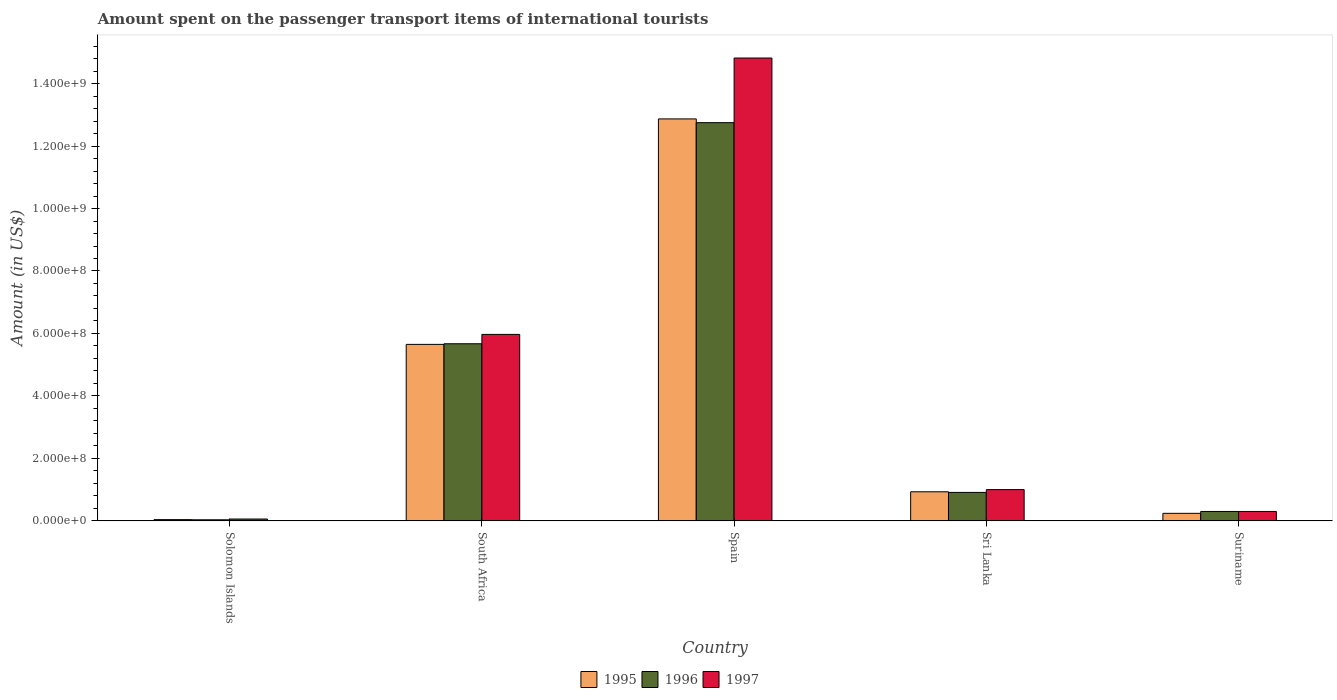How many different coloured bars are there?
Give a very brief answer. 3. How many groups of bars are there?
Provide a short and direct response. 5. Are the number of bars on each tick of the X-axis equal?
Ensure brevity in your answer.  Yes. How many bars are there on the 2nd tick from the left?
Ensure brevity in your answer.  3. How many bars are there on the 4th tick from the right?
Your answer should be very brief. 3. What is the label of the 1st group of bars from the left?
Offer a terse response. Solomon Islands. In how many cases, is the number of bars for a given country not equal to the number of legend labels?
Ensure brevity in your answer.  0. What is the amount spent on the passenger transport items of international tourists in 1997 in Solomon Islands?
Give a very brief answer. 5.80e+06. Across all countries, what is the maximum amount spent on the passenger transport items of international tourists in 1997?
Keep it short and to the point. 1.48e+09. Across all countries, what is the minimum amount spent on the passenger transport items of international tourists in 1995?
Provide a short and direct response. 3.90e+06. In which country was the amount spent on the passenger transport items of international tourists in 1996 minimum?
Ensure brevity in your answer.  Solomon Islands. What is the total amount spent on the passenger transport items of international tourists in 1996 in the graph?
Provide a short and direct response. 1.97e+09. What is the difference between the amount spent on the passenger transport items of international tourists in 1996 in Spain and that in Sri Lanka?
Keep it short and to the point. 1.18e+09. What is the difference between the amount spent on the passenger transport items of international tourists in 1995 in South Africa and the amount spent on the passenger transport items of international tourists in 1996 in Spain?
Make the answer very short. -7.10e+08. What is the average amount spent on the passenger transport items of international tourists in 1995 per country?
Ensure brevity in your answer.  3.95e+08. In how many countries, is the amount spent on the passenger transport items of international tourists in 1995 greater than 1400000000 US$?
Your answer should be very brief. 0. What is the ratio of the amount spent on the passenger transport items of international tourists in 1996 in Spain to that in Sri Lanka?
Give a very brief answer. 14.01. Is the amount spent on the passenger transport items of international tourists in 1996 in Spain less than that in Suriname?
Offer a very short reply. No. What is the difference between the highest and the second highest amount spent on the passenger transport items of international tourists in 1997?
Ensure brevity in your answer.  1.38e+09. What is the difference between the highest and the lowest amount spent on the passenger transport items of international tourists in 1997?
Give a very brief answer. 1.48e+09. What does the 1st bar from the right in Sri Lanka represents?
Your answer should be very brief. 1997. How many countries are there in the graph?
Your response must be concise. 5. What is the difference between two consecutive major ticks on the Y-axis?
Your answer should be compact. 2.00e+08. Are the values on the major ticks of Y-axis written in scientific E-notation?
Your response must be concise. Yes. Does the graph contain grids?
Keep it short and to the point. No. Where does the legend appear in the graph?
Provide a short and direct response. Bottom center. How are the legend labels stacked?
Make the answer very short. Horizontal. What is the title of the graph?
Your answer should be compact. Amount spent on the passenger transport items of international tourists. Does "2004" appear as one of the legend labels in the graph?
Provide a short and direct response. No. What is the label or title of the Y-axis?
Provide a short and direct response. Amount (in US$). What is the Amount (in US$) in 1995 in Solomon Islands?
Offer a terse response. 3.90e+06. What is the Amount (in US$) of 1996 in Solomon Islands?
Offer a very short reply. 3.30e+06. What is the Amount (in US$) of 1997 in Solomon Islands?
Keep it short and to the point. 5.80e+06. What is the Amount (in US$) in 1995 in South Africa?
Provide a short and direct response. 5.65e+08. What is the Amount (in US$) in 1996 in South Africa?
Ensure brevity in your answer.  5.67e+08. What is the Amount (in US$) in 1997 in South Africa?
Your answer should be very brief. 5.97e+08. What is the Amount (in US$) of 1995 in Spain?
Your answer should be very brief. 1.29e+09. What is the Amount (in US$) in 1996 in Spain?
Your answer should be very brief. 1.28e+09. What is the Amount (in US$) of 1997 in Spain?
Offer a very short reply. 1.48e+09. What is the Amount (in US$) of 1995 in Sri Lanka?
Provide a succinct answer. 9.30e+07. What is the Amount (in US$) in 1996 in Sri Lanka?
Give a very brief answer. 9.10e+07. What is the Amount (in US$) of 1995 in Suriname?
Your answer should be compact. 2.40e+07. What is the Amount (in US$) of 1996 in Suriname?
Make the answer very short. 3.00e+07. What is the Amount (in US$) of 1997 in Suriname?
Ensure brevity in your answer.  3.00e+07. Across all countries, what is the maximum Amount (in US$) of 1995?
Your answer should be compact. 1.29e+09. Across all countries, what is the maximum Amount (in US$) in 1996?
Your response must be concise. 1.28e+09. Across all countries, what is the maximum Amount (in US$) in 1997?
Provide a succinct answer. 1.48e+09. Across all countries, what is the minimum Amount (in US$) in 1995?
Your response must be concise. 3.90e+06. Across all countries, what is the minimum Amount (in US$) of 1996?
Provide a short and direct response. 3.30e+06. Across all countries, what is the minimum Amount (in US$) in 1997?
Offer a very short reply. 5.80e+06. What is the total Amount (in US$) of 1995 in the graph?
Give a very brief answer. 1.97e+09. What is the total Amount (in US$) in 1996 in the graph?
Give a very brief answer. 1.97e+09. What is the total Amount (in US$) of 1997 in the graph?
Offer a very short reply. 2.21e+09. What is the difference between the Amount (in US$) in 1995 in Solomon Islands and that in South Africa?
Keep it short and to the point. -5.61e+08. What is the difference between the Amount (in US$) of 1996 in Solomon Islands and that in South Africa?
Offer a terse response. -5.64e+08. What is the difference between the Amount (in US$) in 1997 in Solomon Islands and that in South Africa?
Make the answer very short. -5.91e+08. What is the difference between the Amount (in US$) of 1995 in Solomon Islands and that in Spain?
Keep it short and to the point. -1.28e+09. What is the difference between the Amount (in US$) in 1996 in Solomon Islands and that in Spain?
Give a very brief answer. -1.27e+09. What is the difference between the Amount (in US$) of 1997 in Solomon Islands and that in Spain?
Offer a terse response. -1.48e+09. What is the difference between the Amount (in US$) of 1995 in Solomon Islands and that in Sri Lanka?
Make the answer very short. -8.91e+07. What is the difference between the Amount (in US$) of 1996 in Solomon Islands and that in Sri Lanka?
Your answer should be very brief. -8.77e+07. What is the difference between the Amount (in US$) in 1997 in Solomon Islands and that in Sri Lanka?
Give a very brief answer. -9.42e+07. What is the difference between the Amount (in US$) of 1995 in Solomon Islands and that in Suriname?
Keep it short and to the point. -2.01e+07. What is the difference between the Amount (in US$) in 1996 in Solomon Islands and that in Suriname?
Your answer should be very brief. -2.67e+07. What is the difference between the Amount (in US$) in 1997 in Solomon Islands and that in Suriname?
Keep it short and to the point. -2.42e+07. What is the difference between the Amount (in US$) in 1995 in South Africa and that in Spain?
Ensure brevity in your answer.  -7.22e+08. What is the difference between the Amount (in US$) in 1996 in South Africa and that in Spain?
Your answer should be compact. -7.08e+08. What is the difference between the Amount (in US$) of 1997 in South Africa and that in Spain?
Make the answer very short. -8.85e+08. What is the difference between the Amount (in US$) of 1995 in South Africa and that in Sri Lanka?
Provide a short and direct response. 4.72e+08. What is the difference between the Amount (in US$) of 1996 in South Africa and that in Sri Lanka?
Provide a short and direct response. 4.76e+08. What is the difference between the Amount (in US$) of 1997 in South Africa and that in Sri Lanka?
Ensure brevity in your answer.  4.97e+08. What is the difference between the Amount (in US$) in 1995 in South Africa and that in Suriname?
Give a very brief answer. 5.41e+08. What is the difference between the Amount (in US$) of 1996 in South Africa and that in Suriname?
Offer a very short reply. 5.37e+08. What is the difference between the Amount (in US$) in 1997 in South Africa and that in Suriname?
Provide a succinct answer. 5.67e+08. What is the difference between the Amount (in US$) in 1995 in Spain and that in Sri Lanka?
Give a very brief answer. 1.19e+09. What is the difference between the Amount (in US$) of 1996 in Spain and that in Sri Lanka?
Offer a terse response. 1.18e+09. What is the difference between the Amount (in US$) in 1997 in Spain and that in Sri Lanka?
Your response must be concise. 1.38e+09. What is the difference between the Amount (in US$) in 1995 in Spain and that in Suriname?
Ensure brevity in your answer.  1.26e+09. What is the difference between the Amount (in US$) in 1996 in Spain and that in Suriname?
Offer a terse response. 1.24e+09. What is the difference between the Amount (in US$) in 1997 in Spain and that in Suriname?
Your response must be concise. 1.45e+09. What is the difference between the Amount (in US$) of 1995 in Sri Lanka and that in Suriname?
Make the answer very short. 6.90e+07. What is the difference between the Amount (in US$) in 1996 in Sri Lanka and that in Suriname?
Keep it short and to the point. 6.10e+07. What is the difference between the Amount (in US$) in 1997 in Sri Lanka and that in Suriname?
Ensure brevity in your answer.  7.00e+07. What is the difference between the Amount (in US$) in 1995 in Solomon Islands and the Amount (in US$) in 1996 in South Africa?
Your answer should be very brief. -5.63e+08. What is the difference between the Amount (in US$) of 1995 in Solomon Islands and the Amount (in US$) of 1997 in South Africa?
Provide a succinct answer. -5.93e+08. What is the difference between the Amount (in US$) of 1996 in Solomon Islands and the Amount (in US$) of 1997 in South Africa?
Give a very brief answer. -5.94e+08. What is the difference between the Amount (in US$) of 1995 in Solomon Islands and the Amount (in US$) of 1996 in Spain?
Your response must be concise. -1.27e+09. What is the difference between the Amount (in US$) of 1995 in Solomon Islands and the Amount (in US$) of 1997 in Spain?
Give a very brief answer. -1.48e+09. What is the difference between the Amount (in US$) in 1996 in Solomon Islands and the Amount (in US$) in 1997 in Spain?
Ensure brevity in your answer.  -1.48e+09. What is the difference between the Amount (in US$) of 1995 in Solomon Islands and the Amount (in US$) of 1996 in Sri Lanka?
Your answer should be compact. -8.71e+07. What is the difference between the Amount (in US$) of 1995 in Solomon Islands and the Amount (in US$) of 1997 in Sri Lanka?
Your answer should be very brief. -9.61e+07. What is the difference between the Amount (in US$) in 1996 in Solomon Islands and the Amount (in US$) in 1997 in Sri Lanka?
Offer a terse response. -9.67e+07. What is the difference between the Amount (in US$) in 1995 in Solomon Islands and the Amount (in US$) in 1996 in Suriname?
Ensure brevity in your answer.  -2.61e+07. What is the difference between the Amount (in US$) in 1995 in Solomon Islands and the Amount (in US$) in 1997 in Suriname?
Offer a very short reply. -2.61e+07. What is the difference between the Amount (in US$) of 1996 in Solomon Islands and the Amount (in US$) of 1997 in Suriname?
Make the answer very short. -2.67e+07. What is the difference between the Amount (in US$) in 1995 in South Africa and the Amount (in US$) in 1996 in Spain?
Give a very brief answer. -7.10e+08. What is the difference between the Amount (in US$) of 1995 in South Africa and the Amount (in US$) of 1997 in Spain?
Your answer should be very brief. -9.17e+08. What is the difference between the Amount (in US$) in 1996 in South Africa and the Amount (in US$) in 1997 in Spain?
Provide a short and direct response. -9.15e+08. What is the difference between the Amount (in US$) in 1995 in South Africa and the Amount (in US$) in 1996 in Sri Lanka?
Make the answer very short. 4.74e+08. What is the difference between the Amount (in US$) in 1995 in South Africa and the Amount (in US$) in 1997 in Sri Lanka?
Ensure brevity in your answer.  4.65e+08. What is the difference between the Amount (in US$) in 1996 in South Africa and the Amount (in US$) in 1997 in Sri Lanka?
Offer a terse response. 4.67e+08. What is the difference between the Amount (in US$) in 1995 in South Africa and the Amount (in US$) in 1996 in Suriname?
Provide a succinct answer. 5.35e+08. What is the difference between the Amount (in US$) of 1995 in South Africa and the Amount (in US$) of 1997 in Suriname?
Offer a very short reply. 5.35e+08. What is the difference between the Amount (in US$) of 1996 in South Africa and the Amount (in US$) of 1997 in Suriname?
Make the answer very short. 5.37e+08. What is the difference between the Amount (in US$) in 1995 in Spain and the Amount (in US$) in 1996 in Sri Lanka?
Give a very brief answer. 1.20e+09. What is the difference between the Amount (in US$) in 1995 in Spain and the Amount (in US$) in 1997 in Sri Lanka?
Give a very brief answer. 1.19e+09. What is the difference between the Amount (in US$) of 1996 in Spain and the Amount (in US$) of 1997 in Sri Lanka?
Give a very brief answer. 1.18e+09. What is the difference between the Amount (in US$) in 1995 in Spain and the Amount (in US$) in 1996 in Suriname?
Provide a short and direct response. 1.26e+09. What is the difference between the Amount (in US$) in 1995 in Spain and the Amount (in US$) in 1997 in Suriname?
Keep it short and to the point. 1.26e+09. What is the difference between the Amount (in US$) in 1996 in Spain and the Amount (in US$) in 1997 in Suriname?
Ensure brevity in your answer.  1.24e+09. What is the difference between the Amount (in US$) of 1995 in Sri Lanka and the Amount (in US$) of 1996 in Suriname?
Keep it short and to the point. 6.30e+07. What is the difference between the Amount (in US$) in 1995 in Sri Lanka and the Amount (in US$) in 1997 in Suriname?
Your answer should be very brief. 6.30e+07. What is the difference between the Amount (in US$) in 1996 in Sri Lanka and the Amount (in US$) in 1997 in Suriname?
Your response must be concise. 6.10e+07. What is the average Amount (in US$) in 1995 per country?
Keep it short and to the point. 3.95e+08. What is the average Amount (in US$) of 1996 per country?
Keep it short and to the point. 3.93e+08. What is the average Amount (in US$) of 1997 per country?
Offer a terse response. 4.43e+08. What is the difference between the Amount (in US$) of 1995 and Amount (in US$) of 1997 in Solomon Islands?
Provide a succinct answer. -1.90e+06. What is the difference between the Amount (in US$) in 1996 and Amount (in US$) in 1997 in Solomon Islands?
Provide a succinct answer. -2.50e+06. What is the difference between the Amount (in US$) in 1995 and Amount (in US$) in 1997 in South Africa?
Ensure brevity in your answer.  -3.20e+07. What is the difference between the Amount (in US$) of 1996 and Amount (in US$) of 1997 in South Africa?
Give a very brief answer. -3.00e+07. What is the difference between the Amount (in US$) of 1995 and Amount (in US$) of 1996 in Spain?
Give a very brief answer. 1.20e+07. What is the difference between the Amount (in US$) of 1995 and Amount (in US$) of 1997 in Spain?
Your response must be concise. -1.95e+08. What is the difference between the Amount (in US$) in 1996 and Amount (in US$) in 1997 in Spain?
Give a very brief answer. -2.07e+08. What is the difference between the Amount (in US$) in 1995 and Amount (in US$) in 1997 in Sri Lanka?
Give a very brief answer. -7.00e+06. What is the difference between the Amount (in US$) of 1996 and Amount (in US$) of 1997 in Sri Lanka?
Ensure brevity in your answer.  -9.00e+06. What is the difference between the Amount (in US$) in 1995 and Amount (in US$) in 1996 in Suriname?
Ensure brevity in your answer.  -6.00e+06. What is the difference between the Amount (in US$) of 1995 and Amount (in US$) of 1997 in Suriname?
Provide a succinct answer. -6.00e+06. What is the ratio of the Amount (in US$) of 1995 in Solomon Islands to that in South Africa?
Ensure brevity in your answer.  0.01. What is the ratio of the Amount (in US$) in 1996 in Solomon Islands to that in South Africa?
Give a very brief answer. 0.01. What is the ratio of the Amount (in US$) in 1997 in Solomon Islands to that in South Africa?
Offer a very short reply. 0.01. What is the ratio of the Amount (in US$) of 1995 in Solomon Islands to that in Spain?
Keep it short and to the point. 0. What is the ratio of the Amount (in US$) in 1996 in Solomon Islands to that in Spain?
Give a very brief answer. 0. What is the ratio of the Amount (in US$) of 1997 in Solomon Islands to that in Spain?
Your answer should be compact. 0. What is the ratio of the Amount (in US$) of 1995 in Solomon Islands to that in Sri Lanka?
Your answer should be compact. 0.04. What is the ratio of the Amount (in US$) of 1996 in Solomon Islands to that in Sri Lanka?
Give a very brief answer. 0.04. What is the ratio of the Amount (in US$) in 1997 in Solomon Islands to that in Sri Lanka?
Your answer should be very brief. 0.06. What is the ratio of the Amount (in US$) of 1995 in Solomon Islands to that in Suriname?
Offer a very short reply. 0.16. What is the ratio of the Amount (in US$) of 1996 in Solomon Islands to that in Suriname?
Give a very brief answer. 0.11. What is the ratio of the Amount (in US$) of 1997 in Solomon Islands to that in Suriname?
Provide a succinct answer. 0.19. What is the ratio of the Amount (in US$) in 1995 in South Africa to that in Spain?
Your answer should be compact. 0.44. What is the ratio of the Amount (in US$) in 1996 in South Africa to that in Spain?
Provide a short and direct response. 0.44. What is the ratio of the Amount (in US$) of 1997 in South Africa to that in Spain?
Make the answer very short. 0.4. What is the ratio of the Amount (in US$) in 1995 in South Africa to that in Sri Lanka?
Offer a very short reply. 6.08. What is the ratio of the Amount (in US$) in 1996 in South Africa to that in Sri Lanka?
Offer a very short reply. 6.23. What is the ratio of the Amount (in US$) of 1997 in South Africa to that in Sri Lanka?
Your response must be concise. 5.97. What is the ratio of the Amount (in US$) of 1995 in South Africa to that in Suriname?
Your answer should be compact. 23.54. What is the ratio of the Amount (in US$) in 1996 in South Africa to that in Suriname?
Your answer should be very brief. 18.9. What is the ratio of the Amount (in US$) in 1997 in South Africa to that in Suriname?
Make the answer very short. 19.9. What is the ratio of the Amount (in US$) in 1995 in Spain to that in Sri Lanka?
Ensure brevity in your answer.  13.84. What is the ratio of the Amount (in US$) in 1996 in Spain to that in Sri Lanka?
Offer a very short reply. 14.01. What is the ratio of the Amount (in US$) of 1997 in Spain to that in Sri Lanka?
Offer a very short reply. 14.82. What is the ratio of the Amount (in US$) in 1995 in Spain to that in Suriname?
Provide a succinct answer. 53.62. What is the ratio of the Amount (in US$) in 1996 in Spain to that in Suriname?
Keep it short and to the point. 42.5. What is the ratio of the Amount (in US$) of 1997 in Spain to that in Suriname?
Keep it short and to the point. 49.4. What is the ratio of the Amount (in US$) in 1995 in Sri Lanka to that in Suriname?
Keep it short and to the point. 3.88. What is the ratio of the Amount (in US$) in 1996 in Sri Lanka to that in Suriname?
Ensure brevity in your answer.  3.03. What is the ratio of the Amount (in US$) of 1997 in Sri Lanka to that in Suriname?
Make the answer very short. 3.33. What is the difference between the highest and the second highest Amount (in US$) in 1995?
Make the answer very short. 7.22e+08. What is the difference between the highest and the second highest Amount (in US$) of 1996?
Give a very brief answer. 7.08e+08. What is the difference between the highest and the second highest Amount (in US$) in 1997?
Keep it short and to the point. 8.85e+08. What is the difference between the highest and the lowest Amount (in US$) of 1995?
Offer a very short reply. 1.28e+09. What is the difference between the highest and the lowest Amount (in US$) in 1996?
Your response must be concise. 1.27e+09. What is the difference between the highest and the lowest Amount (in US$) in 1997?
Offer a very short reply. 1.48e+09. 